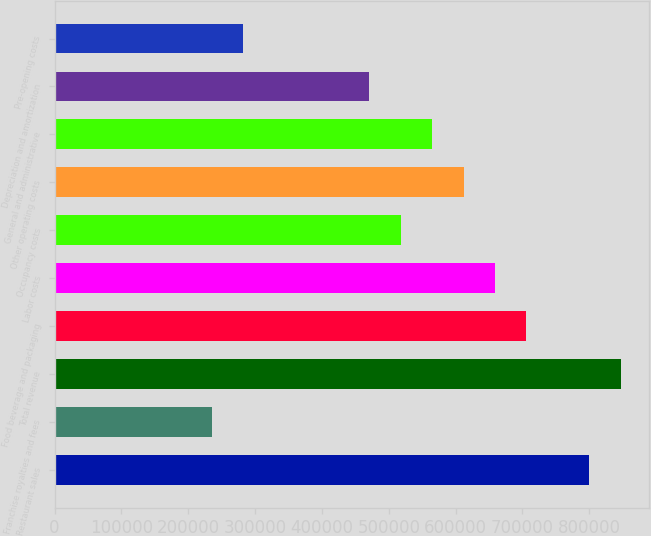Convert chart. <chart><loc_0><loc_0><loc_500><loc_500><bar_chart><fcel>Restaurant sales<fcel>Franchise royalties and fees<fcel>Total revenue<fcel>Food beverage and packaging<fcel>Labor costs<fcel>Occupancy costs<fcel>Other operating costs<fcel>General and administrative<fcel>Depreciation and amortization<fcel>Pre-opening costs<nl><fcel>800226<fcel>235361<fcel>847298<fcel>706081<fcel>659009<fcel>517793<fcel>611937<fcel>564865<fcel>470721<fcel>282433<nl></chart> 